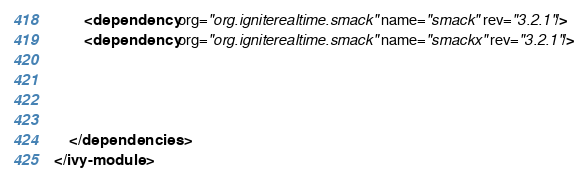<code> <loc_0><loc_0><loc_500><loc_500><_XML_>		<dependency org="org.igniterealtime.smack" name="smack" rev="3.2.1"/>
		<dependency org="org.igniterealtime.smack" name="smackx" rev="3.2.1"/>
		
		
		
		
    </dependencies>
</ivy-module>
</code> 